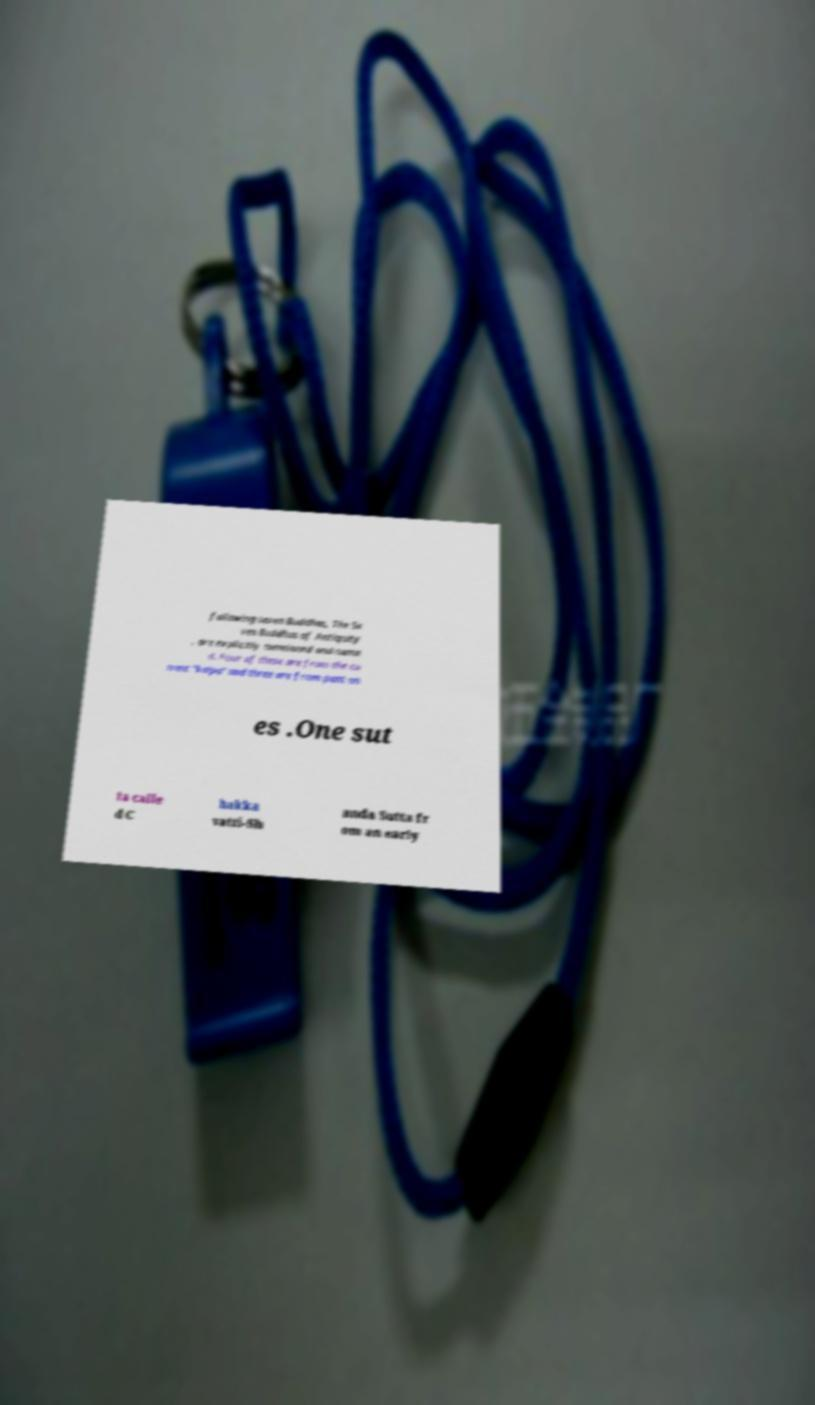I need the written content from this picture converted into text. Can you do that? following seven Buddhas, The Se ven Buddhas of Antiquity , are explicitly mentioned and name d. Four of these are from the cu rrent "kalpa" and three are from past on es .One sut ta calle d C hakka vatti-Sh anda Sutta fr om an early 